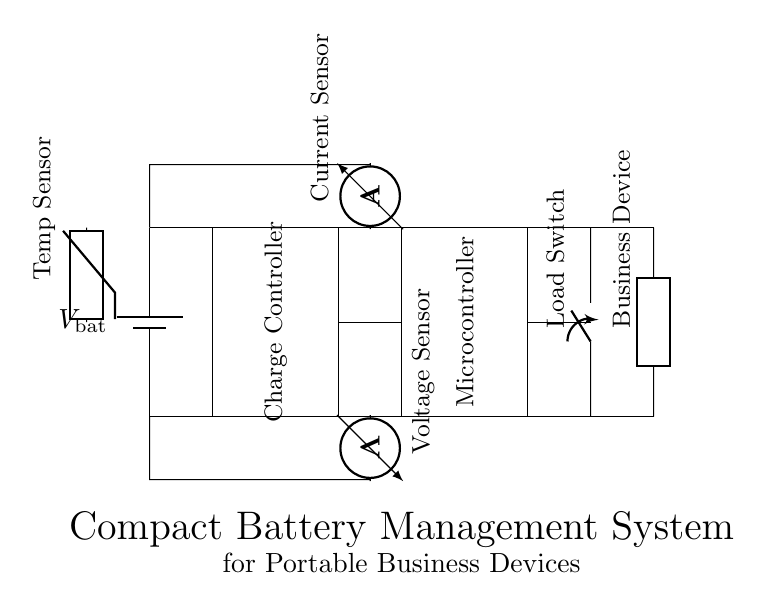What component controls the charging of the battery? The charge controller is specifically marked and designed to manage the charging of the battery.
Answer: Charge Controller What does the voltage sensor measure? The voltage sensor is positioned to measure the voltage across the battery in the circuit.
Answer: Battery Voltage What is the function of the load switch? The load switch operates to control the connection between the power supply and the load, allowing for the device to be turned on and off as needed.
Answer: Control Load How many sensors are present in the circuit? The circuit diagram shows a current sensor, a voltage sensor, and a temperature sensor, totaling three sensors.
Answer: Three What will the current sensor indicate during operation? The current sensor measures the current flowing toward the load (business device), providing real-time feedback on power consumption.
Answer: Current Flow Which component is responsible for processing data in the circuit? The microcontroller is indicated as the component responsible for processing data and managing the overall operation of the circuit.
Answer: Microcontroller What type of device is represented as the load in this circuit? The load in this circuit is identified as a business device, which indicates it is part of a portable application meant for business use.
Answer: Business Device 